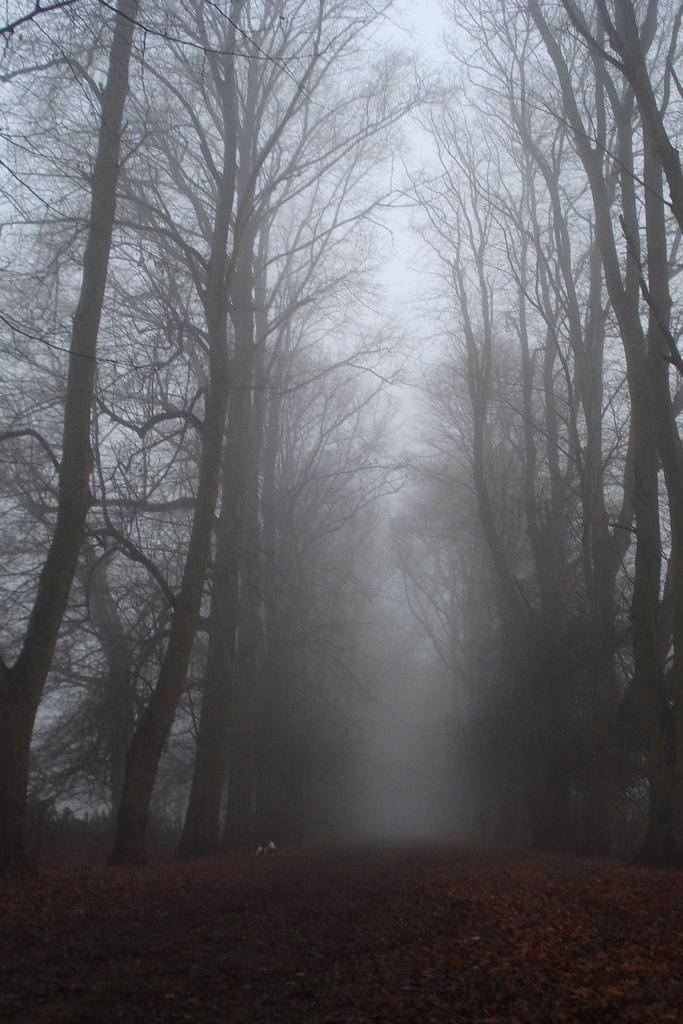What is the main feature in the center of the image? There is a walkway in the center of the image. What type of vegetation is present alongside the walkway? Dry trees are present on either side of the walkway. What atmospheric condition can be observed in the background of the image? There is fog visible in the background of the image. What type of class is being held in the image? There is no class or any indication of a class being held in the image. Can you see a robin perched on one of the dry trees in the image? There is no robin present in the image; only dry trees are visible alongside the walkway. 